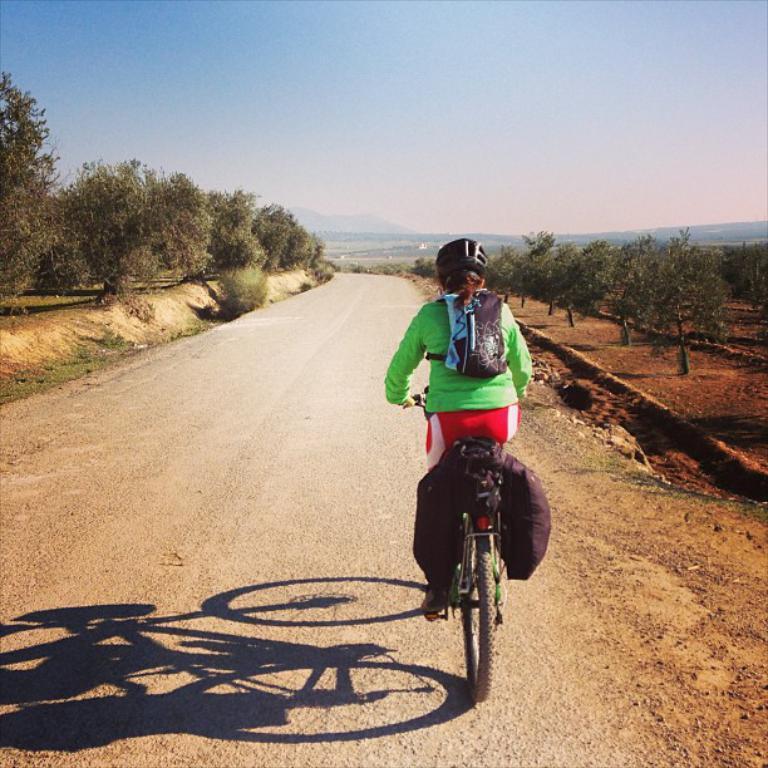In one or two sentences, can you explain what this image depicts? In this image we can see a girl riding a bicycle wearing a helmet. There is road. To the both sides of the image there are trees. At the top of the image there is sky. 